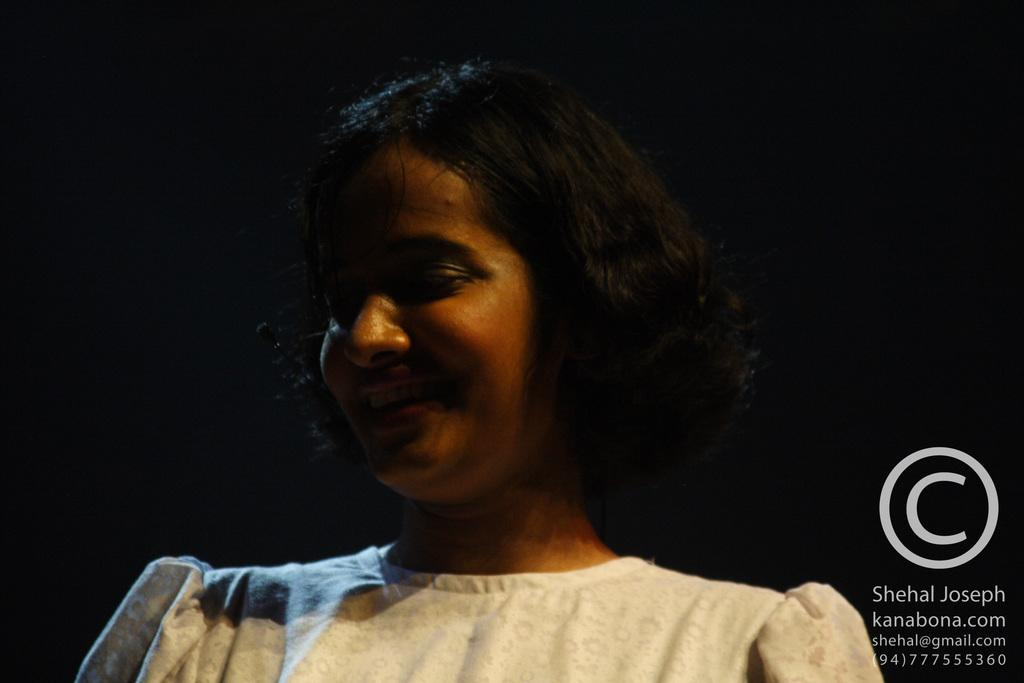Who is present in the image? There is a girl in the image. What type of lift does the girl use to reach the top of the building in the image? There is no building or lift present in the image; it only features a girl. What dish is the girl cooking in the image? There is no cooking or dish present in the image; it only features a girl. 